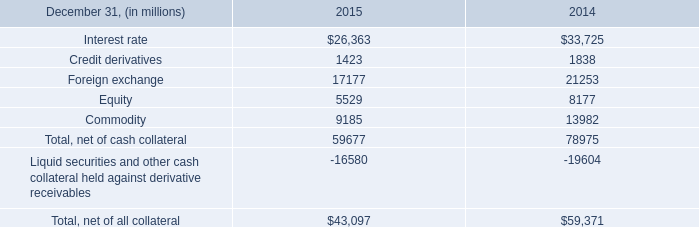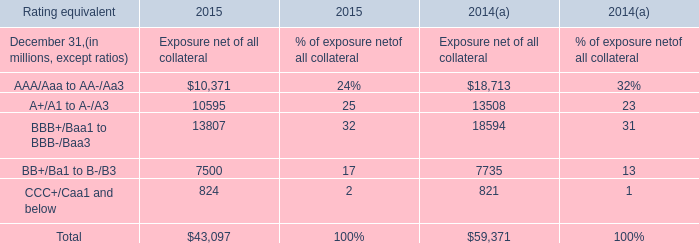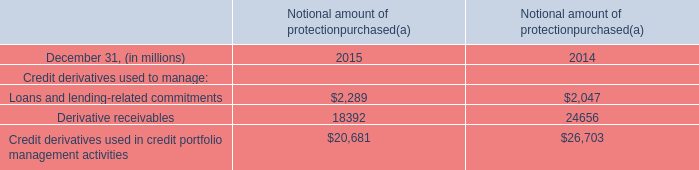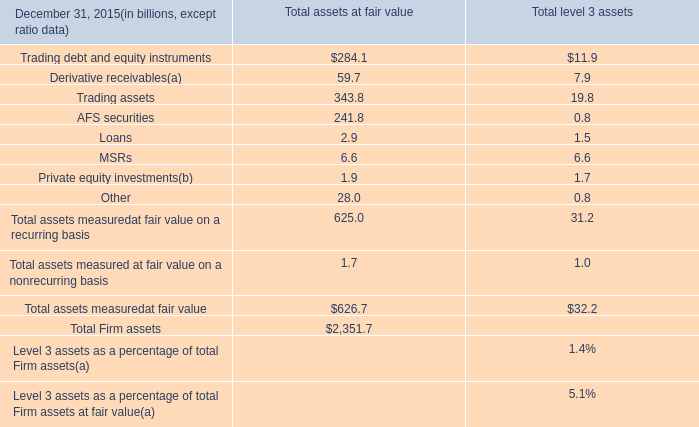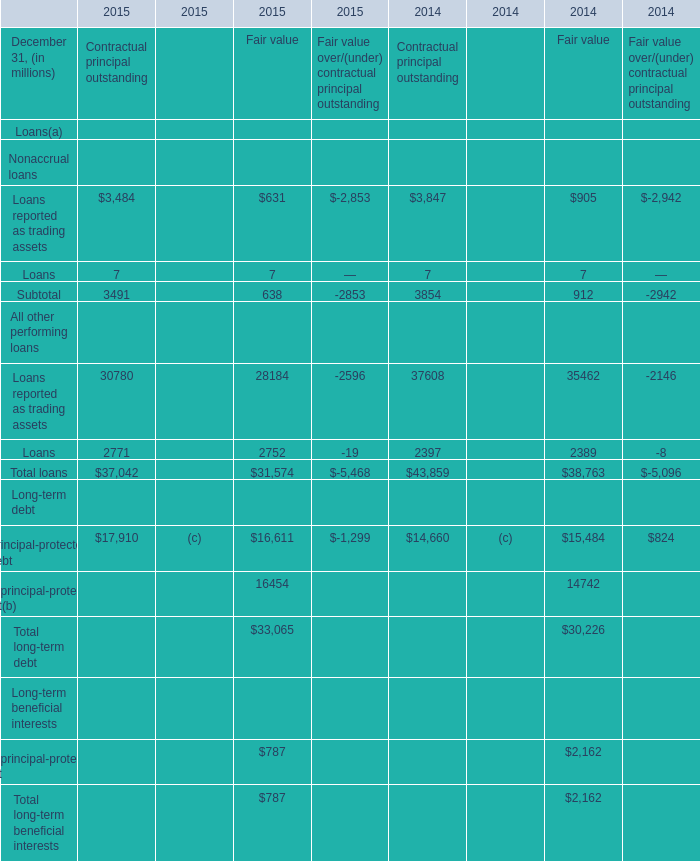What do all Fair value sum up, excluding those negative ones in 2015 for Nonaccrual loans? (in million) 
Computations: (631 + 7)
Answer: 638.0. 